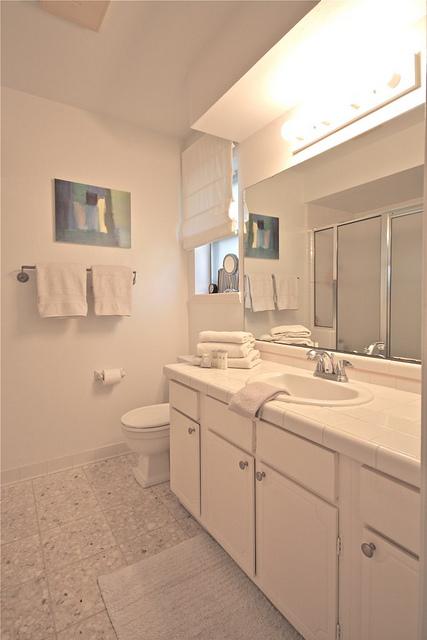Are there window treatments on the window?
Be succinct. No. What type of room is this?
Give a very brief answer. Bathroom. How many people can go to the bathroom at once?
Short answer required. 1. Is there a carpet on the bathroom floor?
Answer briefly. Yes. How many cabinets are in this room?
Keep it brief. 4. Where is the shampoo?
Write a very short answer. In shower. What color is dominant?
Quick response, please. White. What color are the walls?
Quick response, please. White. How old are the cabinets in this room?
Quick response, please. New. What room was the picture taken?
Answer briefly. Bathroom. What type of flooring is in the photo?
Keep it brief. Tile. What color are the walls painted?
Quick response, please. White. Where are the towels?
Write a very short answer. Rack. Where is the toilet paper?
Answer briefly. Wall. What is on top of the mirror?
Short answer required. Lights. What is reflected in the mirror?
Short answer required. Shower. Are there any towels?
Answer briefly. Yes. What room is this?
Keep it brief. Bathroom. What are the cabinets made of?
Write a very short answer. Wood. Does this appear to be a residential bathroom?
Give a very brief answer. Yes. Where is the towel hanging?
Be succinct. Rack. What is hanging on the left wall near the sink?
Quick response, please. Towels. What is the cabinet made of?
Write a very short answer. Wood. Is the toilet lid open or closed?
Concise answer only. Closed. Did someone get very angry?
Answer briefly. No. What type of room is shown?
Be succinct. Bathroom. Why is there a vertical line near the right end of the wall mirror?
Answer briefly. Lights. 